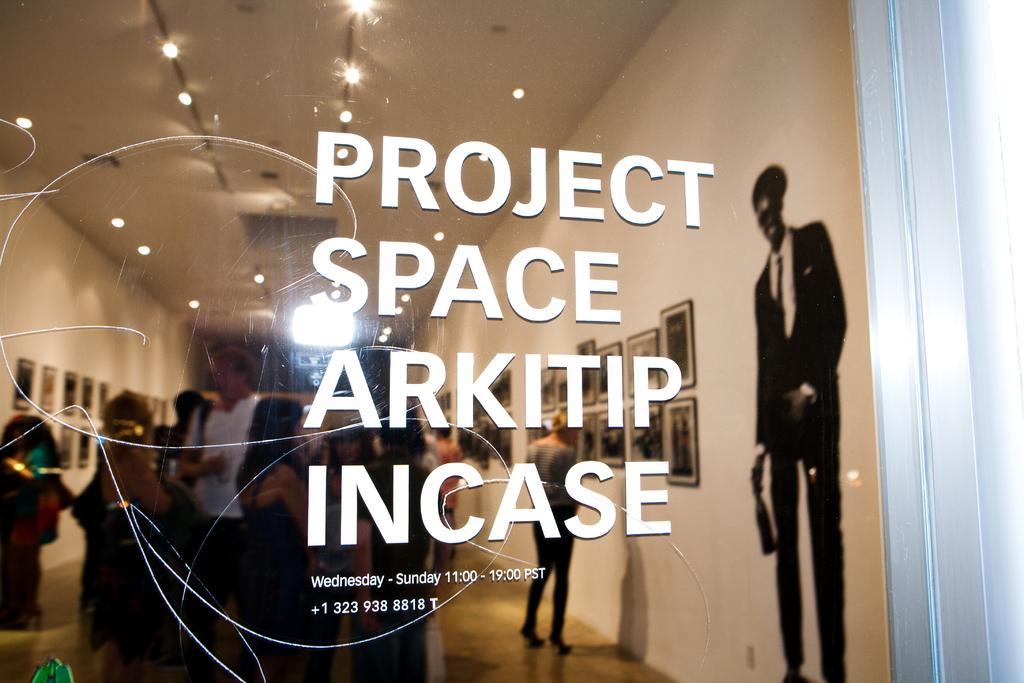In one or two sentences, can you explain what this image depicts? In this image in front there is a glass window and there is some text written on the glass window. Through glass window we can see people standing on the floor. There is a wall with the photo frames on it. On the top of the image there are lights. On the right side of the image there is a depiction of a person. 